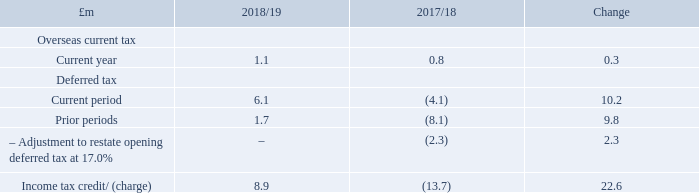A tax credit of £8.9m in the year compared to a £13.7m charge in the prior year. This included a deferred tax credit in the current year of £6.1m, largely reflecting the loss before tax reported of £42.7m and a credit of £1.7m relating to the adjustment of prior period losses and capital allowances. A current year tax credit of £1.1m was in respect of overseas tax.
A deferred tax liability at 30 March 2019 of £13.5m compared to a liability of £12.1m at 31 March 2018. This movement is primarily due to a slightly higher pensions surplus reported at 30 March 2019 compared to 31 March 2018 reflecting the allowability for tax on pensions contribution payments. Recognised and unrecognised deferred tax assets relating to brought forward losses were approximately £44m at 30 March 2019 and equate to around £250m of future taxable profits.
The corporation tax rate and deferred tax rate applied in calculations are 19.0% and 17.0% respectively.
What was the tax credit amount in the current year? £8.9m. What was the deferred tax liability at 30 March 2019? £13.5m. What was the corporation tax rate? 19.0%. What was the percentage change in the overseas current tax from 2017/18 to 2018/19?
Answer scale should be: percent. 1.1 / 0.8 - 1
Answer: 37.5. What was the average deferred tax for 2017/18 and 2018/19?
Answer scale should be: million. (6.1 - 4.1) / 2
Answer: 1. What was the average income tax credit / (charge) for 2017/18 and 2018/19?
Answer scale should be: million. (8.9 - 13.7) / 2
Answer: -2.4. 